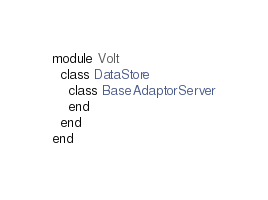Convert code to text. <code><loc_0><loc_0><loc_500><loc_500><_Ruby_>module Volt
  class DataStore
    class BaseAdaptorServer
    end
  end
end
</code> 